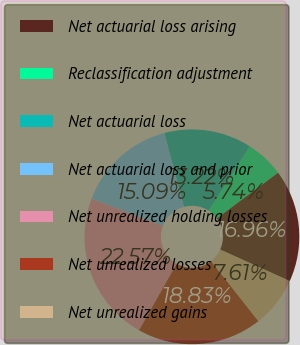<chart> <loc_0><loc_0><loc_500><loc_500><pie_chart><fcel>Net actuarial loss arising<fcel>Reclassification adjustment<fcel>Net actuarial loss<fcel>Net actuarial loss and prior<fcel>Net unrealized holding losses<fcel>Net unrealized losses<fcel>Net unrealized gains<nl><fcel>16.96%<fcel>5.74%<fcel>13.22%<fcel>15.09%<fcel>22.57%<fcel>18.83%<fcel>7.61%<nl></chart> 